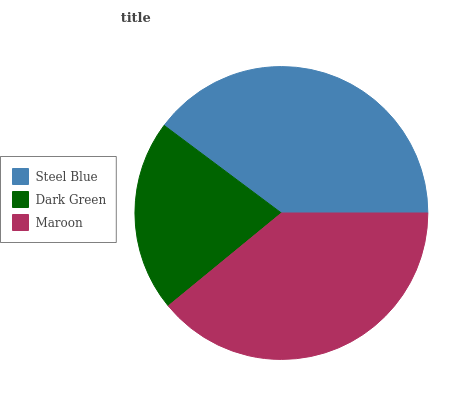Is Dark Green the minimum?
Answer yes or no. Yes. Is Steel Blue the maximum?
Answer yes or no. Yes. Is Maroon the minimum?
Answer yes or no. No. Is Maroon the maximum?
Answer yes or no. No. Is Maroon greater than Dark Green?
Answer yes or no. Yes. Is Dark Green less than Maroon?
Answer yes or no. Yes. Is Dark Green greater than Maroon?
Answer yes or no. No. Is Maroon less than Dark Green?
Answer yes or no. No. Is Maroon the high median?
Answer yes or no. Yes. Is Maroon the low median?
Answer yes or no. Yes. Is Dark Green the high median?
Answer yes or no. No. Is Dark Green the low median?
Answer yes or no. No. 